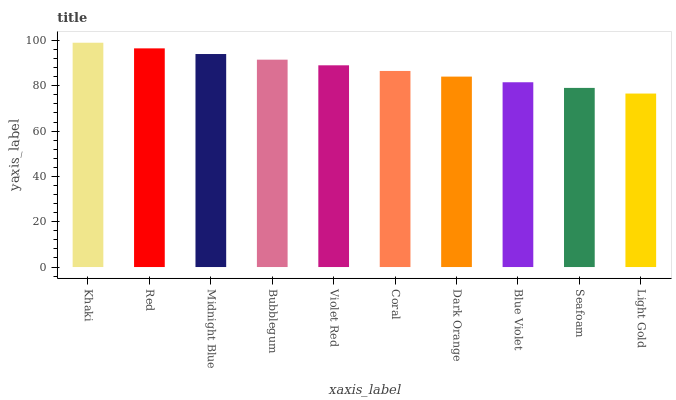Is Light Gold the minimum?
Answer yes or no. Yes. Is Khaki the maximum?
Answer yes or no. Yes. Is Red the minimum?
Answer yes or no. No. Is Red the maximum?
Answer yes or no. No. Is Khaki greater than Red?
Answer yes or no. Yes. Is Red less than Khaki?
Answer yes or no. Yes. Is Red greater than Khaki?
Answer yes or no. No. Is Khaki less than Red?
Answer yes or no. No. Is Violet Red the high median?
Answer yes or no. Yes. Is Coral the low median?
Answer yes or no. Yes. Is Red the high median?
Answer yes or no. No. Is Seafoam the low median?
Answer yes or no. No. 